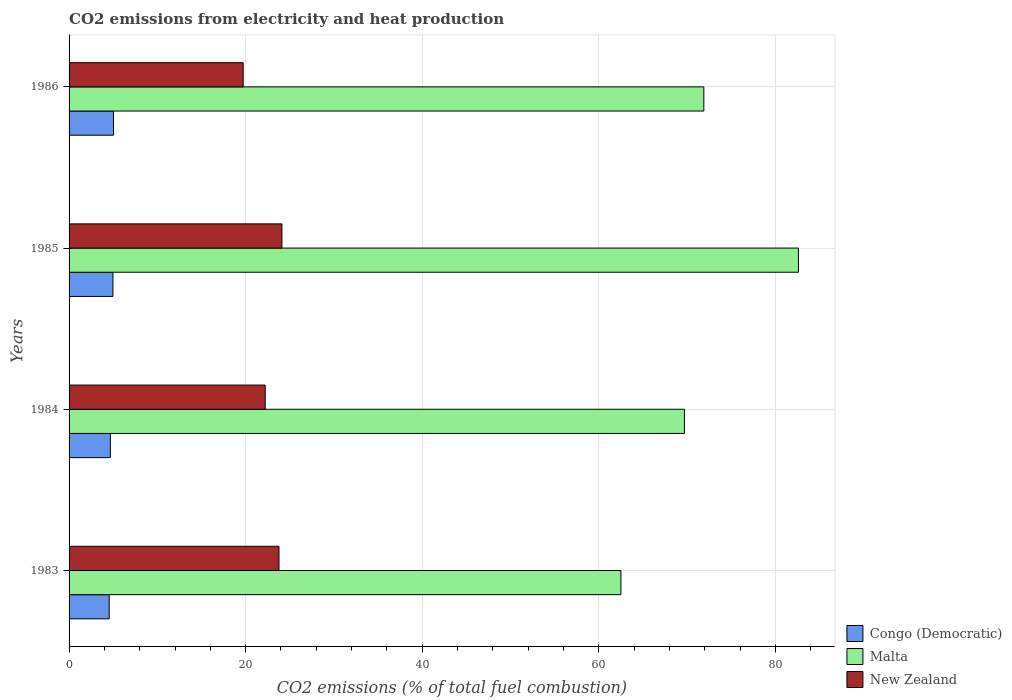Are the number of bars per tick equal to the number of legend labels?
Give a very brief answer. Yes. Are the number of bars on each tick of the Y-axis equal?
Your response must be concise. Yes. How many bars are there on the 3rd tick from the bottom?
Your answer should be compact. 3. What is the label of the 3rd group of bars from the top?
Ensure brevity in your answer.  1984. In how many cases, is the number of bars for a given year not equal to the number of legend labels?
Provide a short and direct response. 0. What is the amount of CO2 emitted in Malta in 1983?
Provide a short and direct response. 62.5. Across all years, what is the maximum amount of CO2 emitted in Congo (Democratic)?
Make the answer very short. 5.03. Across all years, what is the minimum amount of CO2 emitted in Congo (Democratic)?
Your answer should be compact. 4.55. What is the total amount of CO2 emitted in Malta in the graph?
Give a very brief answer. 286.7. What is the difference between the amount of CO2 emitted in Malta in 1985 and that in 1986?
Give a very brief answer. 10.72. What is the difference between the amount of CO2 emitted in Malta in 1983 and the amount of CO2 emitted in Congo (Democratic) in 1984?
Make the answer very short. 57.82. What is the average amount of CO2 emitted in Malta per year?
Ensure brevity in your answer.  71.67. In the year 1985, what is the difference between the amount of CO2 emitted in New Zealand and amount of CO2 emitted in Malta?
Your answer should be compact. -58.5. In how many years, is the amount of CO2 emitted in New Zealand greater than 68 %?
Your answer should be compact. 0. What is the ratio of the amount of CO2 emitted in New Zealand in 1983 to that in 1985?
Provide a succinct answer. 0.99. Is the amount of CO2 emitted in Malta in 1983 less than that in 1984?
Offer a terse response. Yes. Is the difference between the amount of CO2 emitted in New Zealand in 1984 and 1986 greater than the difference between the amount of CO2 emitted in Malta in 1984 and 1986?
Your answer should be very brief. Yes. What is the difference between the highest and the second highest amount of CO2 emitted in New Zealand?
Your answer should be very brief. 0.33. What is the difference between the highest and the lowest amount of CO2 emitted in Malta?
Give a very brief answer. 20.11. In how many years, is the amount of CO2 emitted in Malta greater than the average amount of CO2 emitted in Malta taken over all years?
Your answer should be very brief. 2. Is the sum of the amount of CO2 emitted in Congo (Democratic) in 1983 and 1985 greater than the maximum amount of CO2 emitted in Malta across all years?
Keep it short and to the point. No. What does the 2nd bar from the top in 1983 represents?
Provide a short and direct response. Malta. What does the 3rd bar from the bottom in 1984 represents?
Give a very brief answer. New Zealand. How many bars are there?
Give a very brief answer. 12. Are all the bars in the graph horizontal?
Your answer should be very brief. Yes. How many years are there in the graph?
Offer a very short reply. 4. Are the values on the major ticks of X-axis written in scientific E-notation?
Make the answer very short. No. Does the graph contain grids?
Keep it short and to the point. Yes. What is the title of the graph?
Your answer should be compact. CO2 emissions from electricity and heat production. What is the label or title of the X-axis?
Keep it short and to the point. CO2 emissions (% of total fuel combustion). What is the CO2 emissions (% of total fuel combustion) in Congo (Democratic) in 1983?
Your answer should be compact. 4.55. What is the CO2 emissions (% of total fuel combustion) in Malta in 1983?
Your answer should be very brief. 62.5. What is the CO2 emissions (% of total fuel combustion) of New Zealand in 1983?
Your response must be concise. 23.78. What is the CO2 emissions (% of total fuel combustion) in Congo (Democratic) in 1984?
Offer a very short reply. 4.68. What is the CO2 emissions (% of total fuel combustion) of Malta in 1984?
Offer a terse response. 69.7. What is the CO2 emissions (% of total fuel combustion) in New Zealand in 1984?
Give a very brief answer. 22.22. What is the CO2 emissions (% of total fuel combustion) in Congo (Democratic) in 1985?
Offer a very short reply. 4.97. What is the CO2 emissions (% of total fuel combustion) in Malta in 1985?
Your response must be concise. 82.61. What is the CO2 emissions (% of total fuel combustion) in New Zealand in 1985?
Offer a very short reply. 24.11. What is the CO2 emissions (% of total fuel combustion) in Congo (Democratic) in 1986?
Offer a terse response. 5.03. What is the CO2 emissions (% of total fuel combustion) of Malta in 1986?
Your answer should be compact. 71.89. What is the CO2 emissions (% of total fuel combustion) of New Zealand in 1986?
Offer a terse response. 19.72. Across all years, what is the maximum CO2 emissions (% of total fuel combustion) in Congo (Democratic)?
Give a very brief answer. 5.03. Across all years, what is the maximum CO2 emissions (% of total fuel combustion) of Malta?
Your answer should be compact. 82.61. Across all years, what is the maximum CO2 emissions (% of total fuel combustion) in New Zealand?
Your response must be concise. 24.11. Across all years, what is the minimum CO2 emissions (% of total fuel combustion) in Congo (Democratic)?
Provide a succinct answer. 4.55. Across all years, what is the minimum CO2 emissions (% of total fuel combustion) of Malta?
Offer a terse response. 62.5. Across all years, what is the minimum CO2 emissions (% of total fuel combustion) of New Zealand?
Your answer should be very brief. 19.72. What is the total CO2 emissions (% of total fuel combustion) of Congo (Democratic) in the graph?
Offer a terse response. 19.23. What is the total CO2 emissions (% of total fuel combustion) in Malta in the graph?
Provide a succinct answer. 286.7. What is the total CO2 emissions (% of total fuel combustion) in New Zealand in the graph?
Provide a short and direct response. 89.82. What is the difference between the CO2 emissions (% of total fuel combustion) in Congo (Democratic) in 1983 and that in 1984?
Keep it short and to the point. -0.13. What is the difference between the CO2 emissions (% of total fuel combustion) in Malta in 1983 and that in 1984?
Provide a short and direct response. -7.2. What is the difference between the CO2 emissions (% of total fuel combustion) in New Zealand in 1983 and that in 1984?
Keep it short and to the point. 1.56. What is the difference between the CO2 emissions (% of total fuel combustion) in Congo (Democratic) in 1983 and that in 1985?
Give a very brief answer. -0.42. What is the difference between the CO2 emissions (% of total fuel combustion) of Malta in 1983 and that in 1985?
Provide a short and direct response. -20.11. What is the difference between the CO2 emissions (% of total fuel combustion) in New Zealand in 1983 and that in 1985?
Provide a short and direct response. -0.33. What is the difference between the CO2 emissions (% of total fuel combustion) in Congo (Democratic) in 1983 and that in 1986?
Your response must be concise. -0.49. What is the difference between the CO2 emissions (% of total fuel combustion) in Malta in 1983 and that in 1986?
Your answer should be very brief. -9.39. What is the difference between the CO2 emissions (% of total fuel combustion) of New Zealand in 1983 and that in 1986?
Ensure brevity in your answer.  4.06. What is the difference between the CO2 emissions (% of total fuel combustion) of Congo (Democratic) in 1984 and that in 1985?
Offer a very short reply. -0.29. What is the difference between the CO2 emissions (% of total fuel combustion) in Malta in 1984 and that in 1985?
Give a very brief answer. -12.91. What is the difference between the CO2 emissions (% of total fuel combustion) of New Zealand in 1984 and that in 1985?
Make the answer very short. -1.89. What is the difference between the CO2 emissions (% of total fuel combustion) in Congo (Democratic) in 1984 and that in 1986?
Keep it short and to the point. -0.36. What is the difference between the CO2 emissions (% of total fuel combustion) in Malta in 1984 and that in 1986?
Make the answer very short. -2.19. What is the difference between the CO2 emissions (% of total fuel combustion) of New Zealand in 1984 and that in 1986?
Provide a short and direct response. 2.5. What is the difference between the CO2 emissions (% of total fuel combustion) of Congo (Democratic) in 1985 and that in 1986?
Offer a terse response. -0.06. What is the difference between the CO2 emissions (% of total fuel combustion) in Malta in 1985 and that in 1986?
Keep it short and to the point. 10.72. What is the difference between the CO2 emissions (% of total fuel combustion) in New Zealand in 1985 and that in 1986?
Your response must be concise. 4.39. What is the difference between the CO2 emissions (% of total fuel combustion) of Congo (Democratic) in 1983 and the CO2 emissions (% of total fuel combustion) of Malta in 1984?
Provide a short and direct response. -65.15. What is the difference between the CO2 emissions (% of total fuel combustion) of Congo (Democratic) in 1983 and the CO2 emissions (% of total fuel combustion) of New Zealand in 1984?
Keep it short and to the point. -17.67. What is the difference between the CO2 emissions (% of total fuel combustion) of Malta in 1983 and the CO2 emissions (% of total fuel combustion) of New Zealand in 1984?
Ensure brevity in your answer.  40.28. What is the difference between the CO2 emissions (% of total fuel combustion) in Congo (Democratic) in 1983 and the CO2 emissions (% of total fuel combustion) in Malta in 1985?
Offer a terse response. -78.06. What is the difference between the CO2 emissions (% of total fuel combustion) of Congo (Democratic) in 1983 and the CO2 emissions (% of total fuel combustion) of New Zealand in 1985?
Ensure brevity in your answer.  -19.56. What is the difference between the CO2 emissions (% of total fuel combustion) of Malta in 1983 and the CO2 emissions (% of total fuel combustion) of New Zealand in 1985?
Offer a very short reply. 38.39. What is the difference between the CO2 emissions (% of total fuel combustion) of Congo (Democratic) in 1983 and the CO2 emissions (% of total fuel combustion) of Malta in 1986?
Your answer should be very brief. -67.35. What is the difference between the CO2 emissions (% of total fuel combustion) of Congo (Democratic) in 1983 and the CO2 emissions (% of total fuel combustion) of New Zealand in 1986?
Provide a short and direct response. -15.17. What is the difference between the CO2 emissions (% of total fuel combustion) of Malta in 1983 and the CO2 emissions (% of total fuel combustion) of New Zealand in 1986?
Offer a terse response. 42.78. What is the difference between the CO2 emissions (% of total fuel combustion) in Congo (Democratic) in 1984 and the CO2 emissions (% of total fuel combustion) in Malta in 1985?
Offer a very short reply. -77.93. What is the difference between the CO2 emissions (% of total fuel combustion) of Congo (Democratic) in 1984 and the CO2 emissions (% of total fuel combustion) of New Zealand in 1985?
Your response must be concise. -19.43. What is the difference between the CO2 emissions (% of total fuel combustion) in Malta in 1984 and the CO2 emissions (% of total fuel combustion) in New Zealand in 1985?
Provide a succinct answer. 45.59. What is the difference between the CO2 emissions (% of total fuel combustion) in Congo (Democratic) in 1984 and the CO2 emissions (% of total fuel combustion) in Malta in 1986?
Your response must be concise. -67.21. What is the difference between the CO2 emissions (% of total fuel combustion) of Congo (Democratic) in 1984 and the CO2 emissions (% of total fuel combustion) of New Zealand in 1986?
Make the answer very short. -15.04. What is the difference between the CO2 emissions (% of total fuel combustion) in Malta in 1984 and the CO2 emissions (% of total fuel combustion) in New Zealand in 1986?
Ensure brevity in your answer.  49.98. What is the difference between the CO2 emissions (% of total fuel combustion) in Congo (Democratic) in 1985 and the CO2 emissions (% of total fuel combustion) in Malta in 1986?
Ensure brevity in your answer.  -66.92. What is the difference between the CO2 emissions (% of total fuel combustion) in Congo (Democratic) in 1985 and the CO2 emissions (% of total fuel combustion) in New Zealand in 1986?
Your answer should be very brief. -14.75. What is the difference between the CO2 emissions (% of total fuel combustion) in Malta in 1985 and the CO2 emissions (% of total fuel combustion) in New Zealand in 1986?
Provide a short and direct response. 62.89. What is the average CO2 emissions (% of total fuel combustion) of Congo (Democratic) per year?
Give a very brief answer. 4.81. What is the average CO2 emissions (% of total fuel combustion) of Malta per year?
Make the answer very short. 71.67. What is the average CO2 emissions (% of total fuel combustion) in New Zealand per year?
Make the answer very short. 22.45. In the year 1983, what is the difference between the CO2 emissions (% of total fuel combustion) in Congo (Democratic) and CO2 emissions (% of total fuel combustion) in Malta?
Your answer should be very brief. -57.95. In the year 1983, what is the difference between the CO2 emissions (% of total fuel combustion) of Congo (Democratic) and CO2 emissions (% of total fuel combustion) of New Zealand?
Offer a very short reply. -19.23. In the year 1983, what is the difference between the CO2 emissions (% of total fuel combustion) in Malta and CO2 emissions (% of total fuel combustion) in New Zealand?
Offer a terse response. 38.72. In the year 1984, what is the difference between the CO2 emissions (% of total fuel combustion) of Congo (Democratic) and CO2 emissions (% of total fuel combustion) of Malta?
Offer a very short reply. -65.02. In the year 1984, what is the difference between the CO2 emissions (% of total fuel combustion) of Congo (Democratic) and CO2 emissions (% of total fuel combustion) of New Zealand?
Provide a short and direct response. -17.54. In the year 1984, what is the difference between the CO2 emissions (% of total fuel combustion) in Malta and CO2 emissions (% of total fuel combustion) in New Zealand?
Provide a short and direct response. 47.48. In the year 1985, what is the difference between the CO2 emissions (% of total fuel combustion) in Congo (Democratic) and CO2 emissions (% of total fuel combustion) in Malta?
Keep it short and to the point. -77.64. In the year 1985, what is the difference between the CO2 emissions (% of total fuel combustion) of Congo (Democratic) and CO2 emissions (% of total fuel combustion) of New Zealand?
Provide a short and direct response. -19.14. In the year 1985, what is the difference between the CO2 emissions (% of total fuel combustion) of Malta and CO2 emissions (% of total fuel combustion) of New Zealand?
Offer a terse response. 58.5. In the year 1986, what is the difference between the CO2 emissions (% of total fuel combustion) in Congo (Democratic) and CO2 emissions (% of total fuel combustion) in Malta?
Ensure brevity in your answer.  -66.86. In the year 1986, what is the difference between the CO2 emissions (% of total fuel combustion) in Congo (Democratic) and CO2 emissions (% of total fuel combustion) in New Zealand?
Ensure brevity in your answer.  -14.69. In the year 1986, what is the difference between the CO2 emissions (% of total fuel combustion) in Malta and CO2 emissions (% of total fuel combustion) in New Zealand?
Offer a terse response. 52.17. What is the ratio of the CO2 emissions (% of total fuel combustion) in Congo (Democratic) in 1983 to that in 1984?
Offer a very short reply. 0.97. What is the ratio of the CO2 emissions (% of total fuel combustion) in Malta in 1983 to that in 1984?
Offer a terse response. 0.9. What is the ratio of the CO2 emissions (% of total fuel combustion) in New Zealand in 1983 to that in 1984?
Your answer should be compact. 1.07. What is the ratio of the CO2 emissions (% of total fuel combustion) of Congo (Democratic) in 1983 to that in 1985?
Offer a terse response. 0.91. What is the ratio of the CO2 emissions (% of total fuel combustion) of Malta in 1983 to that in 1985?
Your answer should be compact. 0.76. What is the ratio of the CO2 emissions (% of total fuel combustion) in New Zealand in 1983 to that in 1985?
Offer a terse response. 0.99. What is the ratio of the CO2 emissions (% of total fuel combustion) of Congo (Democratic) in 1983 to that in 1986?
Keep it short and to the point. 0.9. What is the ratio of the CO2 emissions (% of total fuel combustion) of Malta in 1983 to that in 1986?
Your answer should be very brief. 0.87. What is the ratio of the CO2 emissions (% of total fuel combustion) of New Zealand in 1983 to that in 1986?
Offer a terse response. 1.21. What is the ratio of the CO2 emissions (% of total fuel combustion) of Congo (Democratic) in 1984 to that in 1985?
Provide a succinct answer. 0.94. What is the ratio of the CO2 emissions (% of total fuel combustion) of Malta in 1984 to that in 1985?
Provide a succinct answer. 0.84. What is the ratio of the CO2 emissions (% of total fuel combustion) of New Zealand in 1984 to that in 1985?
Keep it short and to the point. 0.92. What is the ratio of the CO2 emissions (% of total fuel combustion) of Congo (Democratic) in 1984 to that in 1986?
Make the answer very short. 0.93. What is the ratio of the CO2 emissions (% of total fuel combustion) of Malta in 1984 to that in 1986?
Ensure brevity in your answer.  0.97. What is the ratio of the CO2 emissions (% of total fuel combustion) of New Zealand in 1984 to that in 1986?
Make the answer very short. 1.13. What is the ratio of the CO2 emissions (% of total fuel combustion) in Congo (Democratic) in 1985 to that in 1986?
Provide a succinct answer. 0.99. What is the ratio of the CO2 emissions (% of total fuel combustion) in Malta in 1985 to that in 1986?
Offer a terse response. 1.15. What is the ratio of the CO2 emissions (% of total fuel combustion) in New Zealand in 1985 to that in 1986?
Your response must be concise. 1.22. What is the difference between the highest and the second highest CO2 emissions (% of total fuel combustion) in Congo (Democratic)?
Your answer should be compact. 0.06. What is the difference between the highest and the second highest CO2 emissions (% of total fuel combustion) in Malta?
Your response must be concise. 10.72. What is the difference between the highest and the second highest CO2 emissions (% of total fuel combustion) in New Zealand?
Your response must be concise. 0.33. What is the difference between the highest and the lowest CO2 emissions (% of total fuel combustion) of Congo (Democratic)?
Your response must be concise. 0.49. What is the difference between the highest and the lowest CO2 emissions (% of total fuel combustion) of Malta?
Provide a short and direct response. 20.11. What is the difference between the highest and the lowest CO2 emissions (% of total fuel combustion) of New Zealand?
Provide a short and direct response. 4.39. 